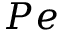<formula> <loc_0><loc_0><loc_500><loc_500>P e</formula> 